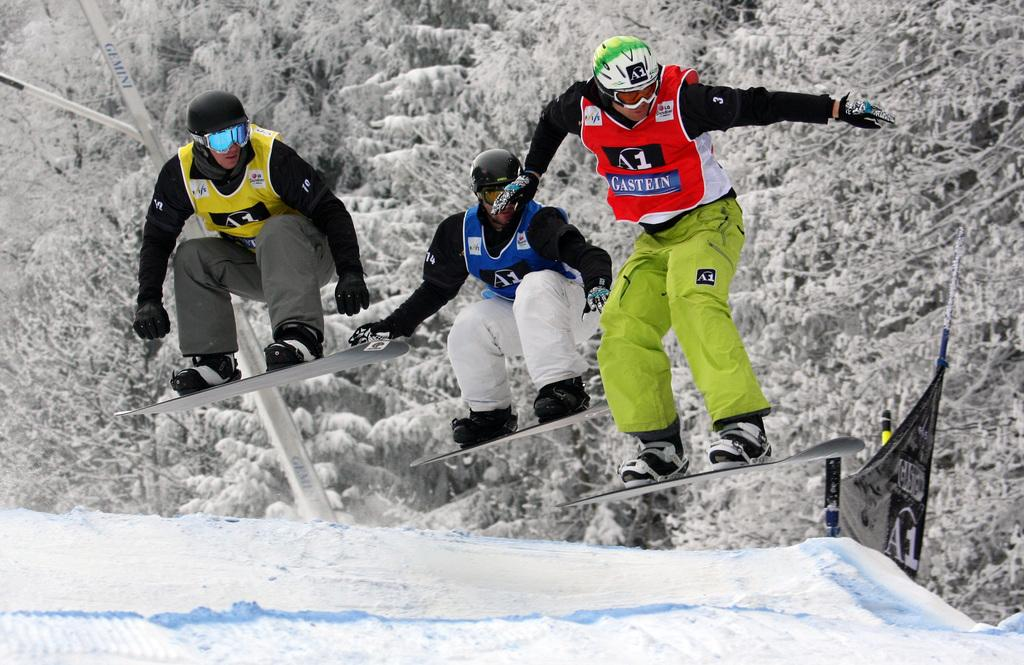How many people are in the image? There are three persons in the image. What are the persons doing in the image? The persons are jumping with skateboards. What is present at the bottom of the image? There is snow at the bottom of the image. What can be seen in the background of the image? There are trees in the background of the image. What arithmetic problem can be solved using the numbers on the skateboards in the image? There is no arithmetic problem present in the image, as it features three persons jumping with skateboards. 